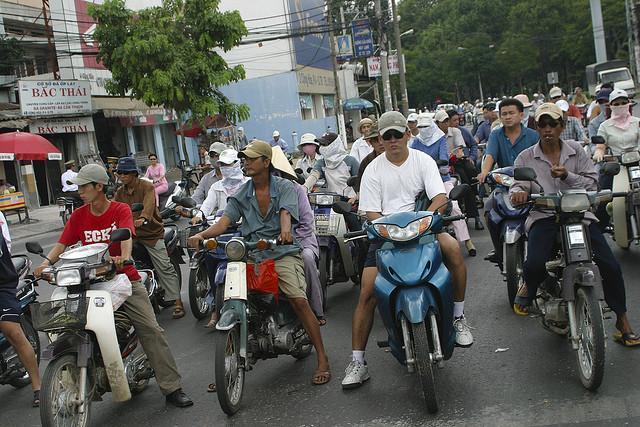How many people are visible?
Give a very brief answer. 10. How many motorcycles can you see?
Give a very brief answer. 6. 